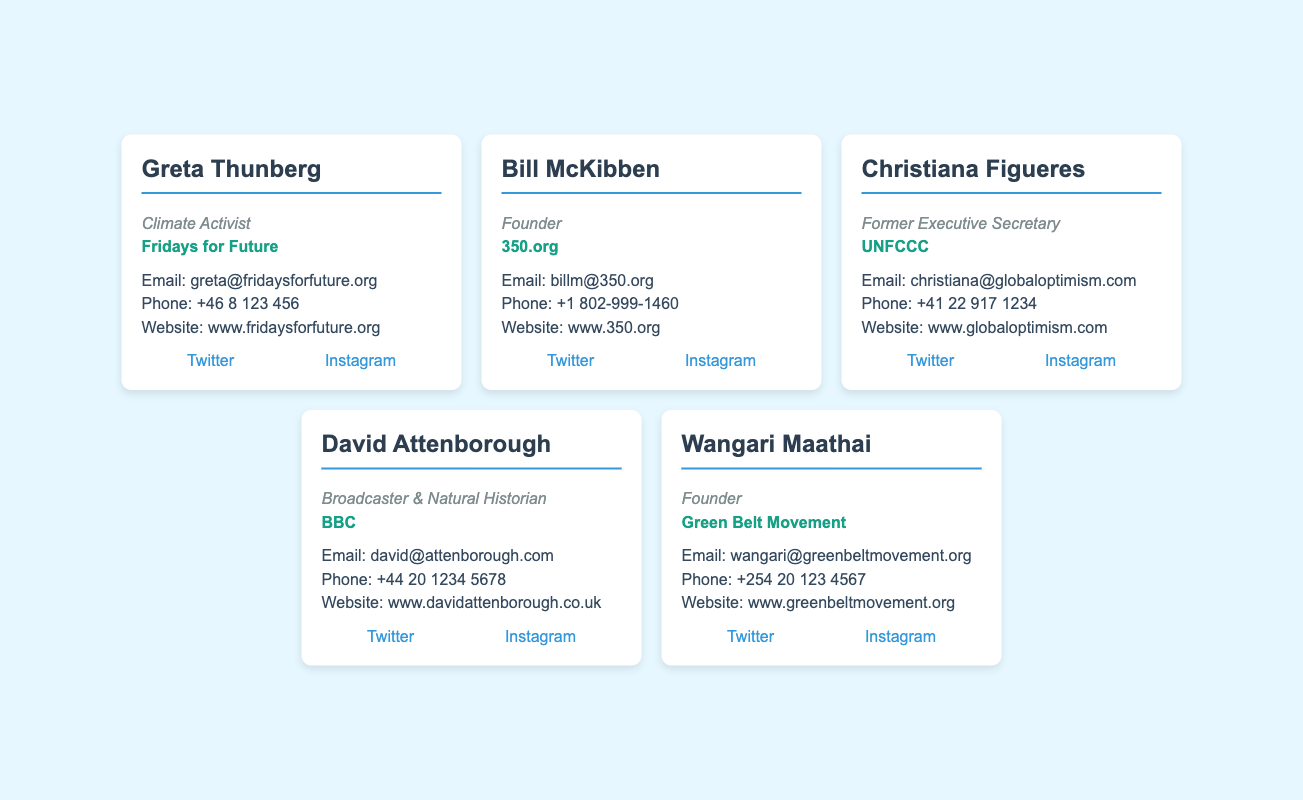What is Greta Thunberg's email? The email address for Greta Thunberg is provided in her business card section, which is greta@fridaysforfuture.org.
Answer: greta@fridaysforfuture.org Who is the founder of 350.org? The business card identifies Bill McKibben as the founder of 350.org.
Answer: Bill McKibben What is the contact phone number for Christiana Figueres? The document states her contact phone number as +41 22 917 1234.
Answer: +41 22 917 1234 What organization is associated with David Attenborough? According to the card, David Attenborough is associated with the BBC.
Answer: BBC Which social media platform does Wangari Maathai have a Twitter account on? The card indicates that she has a Twitter account on Twitter with the handle @WangariMaathai.
Answer: Twitter What title is listed for Christiana Figueres? Her title mentioned on the card is Former Executive Secretary.
Answer: Former Executive Secretary How many influencers are listed in the document? The document contains business cards for five key environmental advocates and influencers.
Answer: Five What does the card for Greta Thunberg highlight? The card highlights her role as a Climate Activist and her affiliation with Fridays for Future.
Answer: Climate Activist, Fridays for Future Where can you visit Bill McKibben's website? The business card provides his website URL as www.350.org.
Answer: www.350.org 